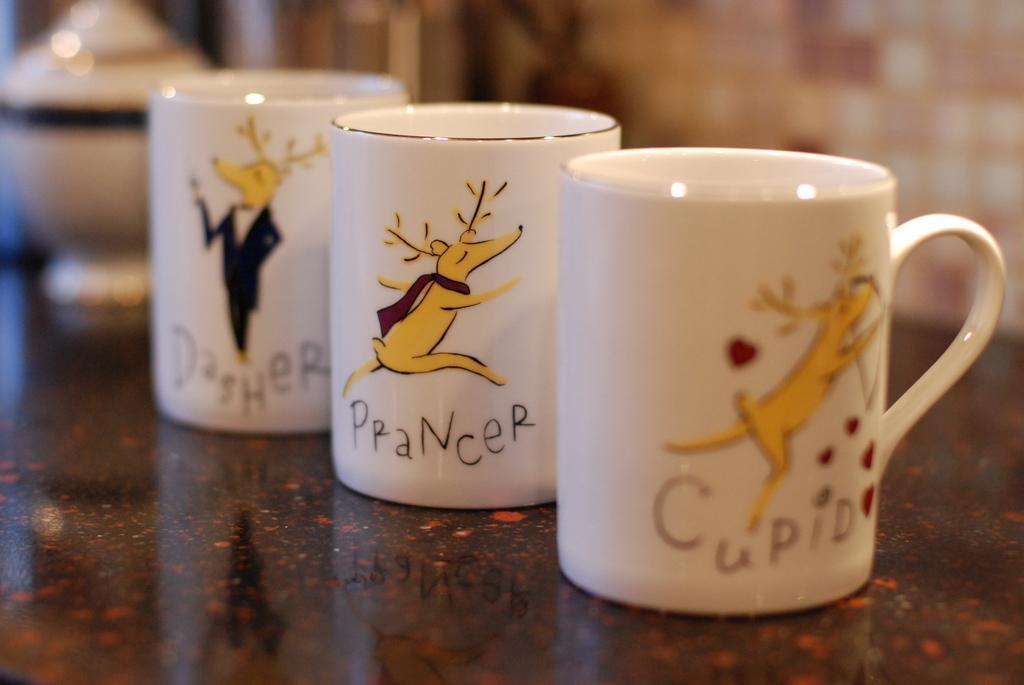Describe this image in one or two sentences. In this image we can see mugs on the surface. In the background of the image there is wall. 